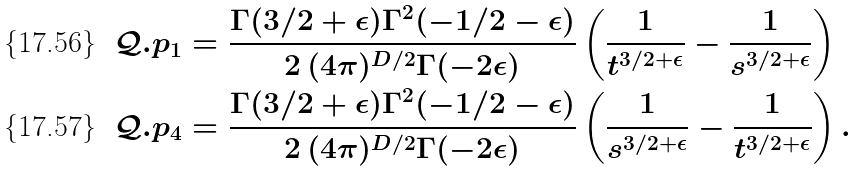Convert formula to latex. <formula><loc_0><loc_0><loc_500><loc_500>& \mathcal { Q } . p _ { 1 } = \frac { \Gamma ( 3 / 2 + \epsilon ) \Gamma ^ { 2 } ( - 1 / 2 - \epsilon ) } { 2 \, ( 4 \pi ) ^ { D / 2 } \Gamma ( - 2 \epsilon ) } \left ( \frac { 1 } { t ^ { 3 / 2 + \epsilon } } - \frac { 1 } { s ^ { 3 / 2 + \epsilon } } \right ) \\ & \mathcal { Q } . p _ { 4 } = \frac { \Gamma ( 3 / 2 + \epsilon ) \Gamma ^ { 2 } ( - 1 / 2 - \epsilon ) } { 2 \, ( 4 \pi ) ^ { D / 2 } \Gamma ( - 2 \epsilon ) } \left ( \frac { 1 } { s ^ { 3 / 2 + \epsilon } } - \frac { 1 } { t ^ { 3 / 2 + \epsilon } } \right ) .</formula> 